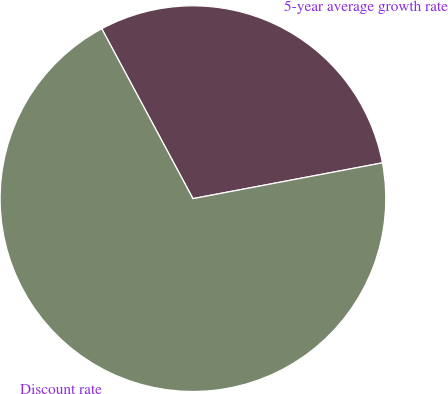Convert chart. <chart><loc_0><loc_0><loc_500><loc_500><pie_chart><fcel>5-year average growth rate<fcel>Discount rate<nl><fcel>29.87%<fcel>70.13%<nl></chart> 